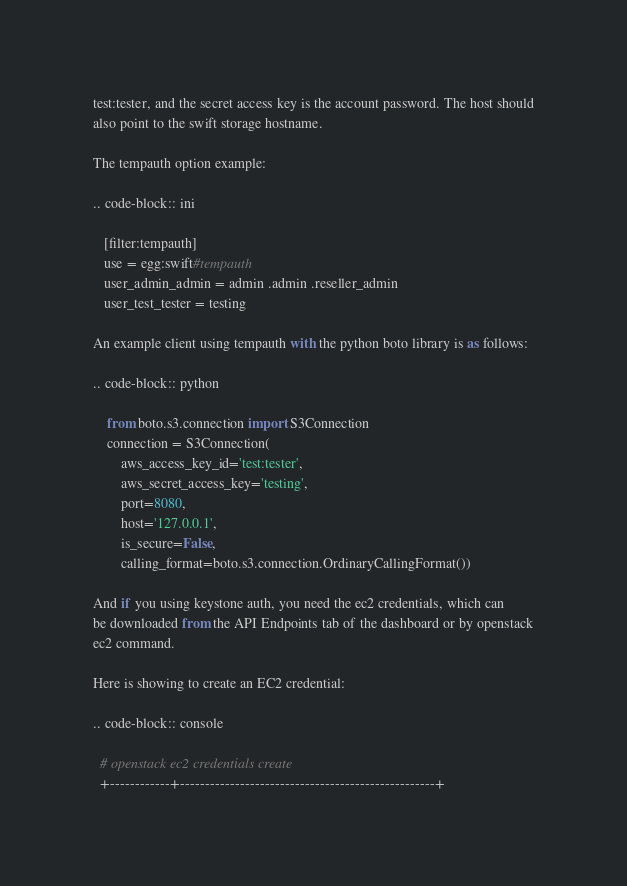<code> <loc_0><loc_0><loc_500><loc_500><_Python_>test:tester, and the secret access key is the account password. The host should
also point to the swift storage hostname.

The tempauth option example:

.. code-block:: ini

   [filter:tempauth]
   use = egg:swift#tempauth
   user_admin_admin = admin .admin .reseller_admin
   user_test_tester = testing

An example client using tempauth with the python boto library is as follows:

.. code-block:: python

    from boto.s3.connection import S3Connection
    connection = S3Connection(
        aws_access_key_id='test:tester',
        aws_secret_access_key='testing',
        port=8080,
        host='127.0.0.1',
        is_secure=False,
        calling_format=boto.s3.connection.OrdinaryCallingFormat())

And if you using keystone auth, you need the ec2 credentials, which can
be downloaded from the API Endpoints tab of the dashboard or by openstack
ec2 command.

Here is showing to create an EC2 credential:

.. code-block:: console

  # openstack ec2 credentials create
  +------------+---------------------------------------------------+</code> 